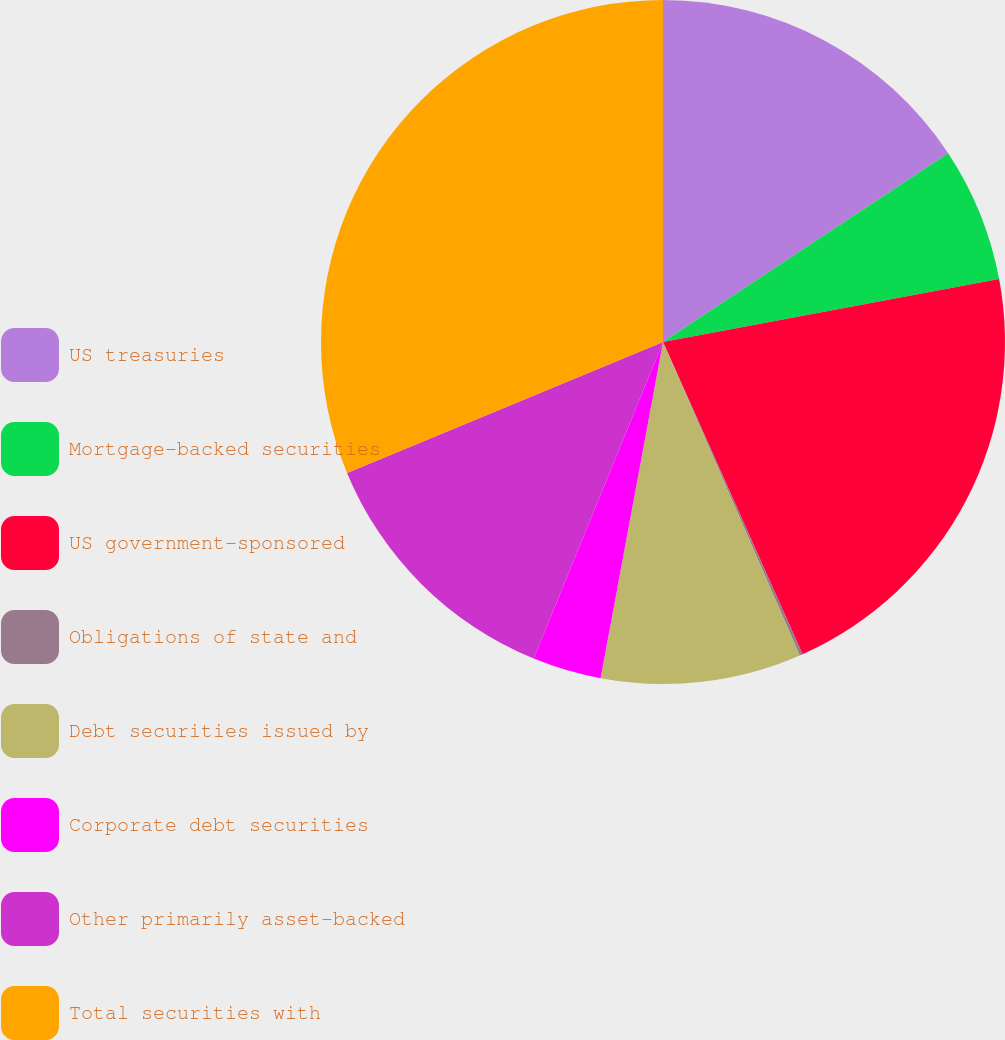<chart> <loc_0><loc_0><loc_500><loc_500><pie_chart><fcel>US treasuries<fcel>Mortgage-backed securities<fcel>US government-sponsored<fcel>Obligations of state and<fcel>Debt securities issued by<fcel>Corporate debt securities<fcel>Other primarily asset-backed<fcel>Total securities with<nl><fcel>15.69%<fcel>6.36%<fcel>21.26%<fcel>0.14%<fcel>9.47%<fcel>3.25%<fcel>12.58%<fcel>31.25%<nl></chart> 